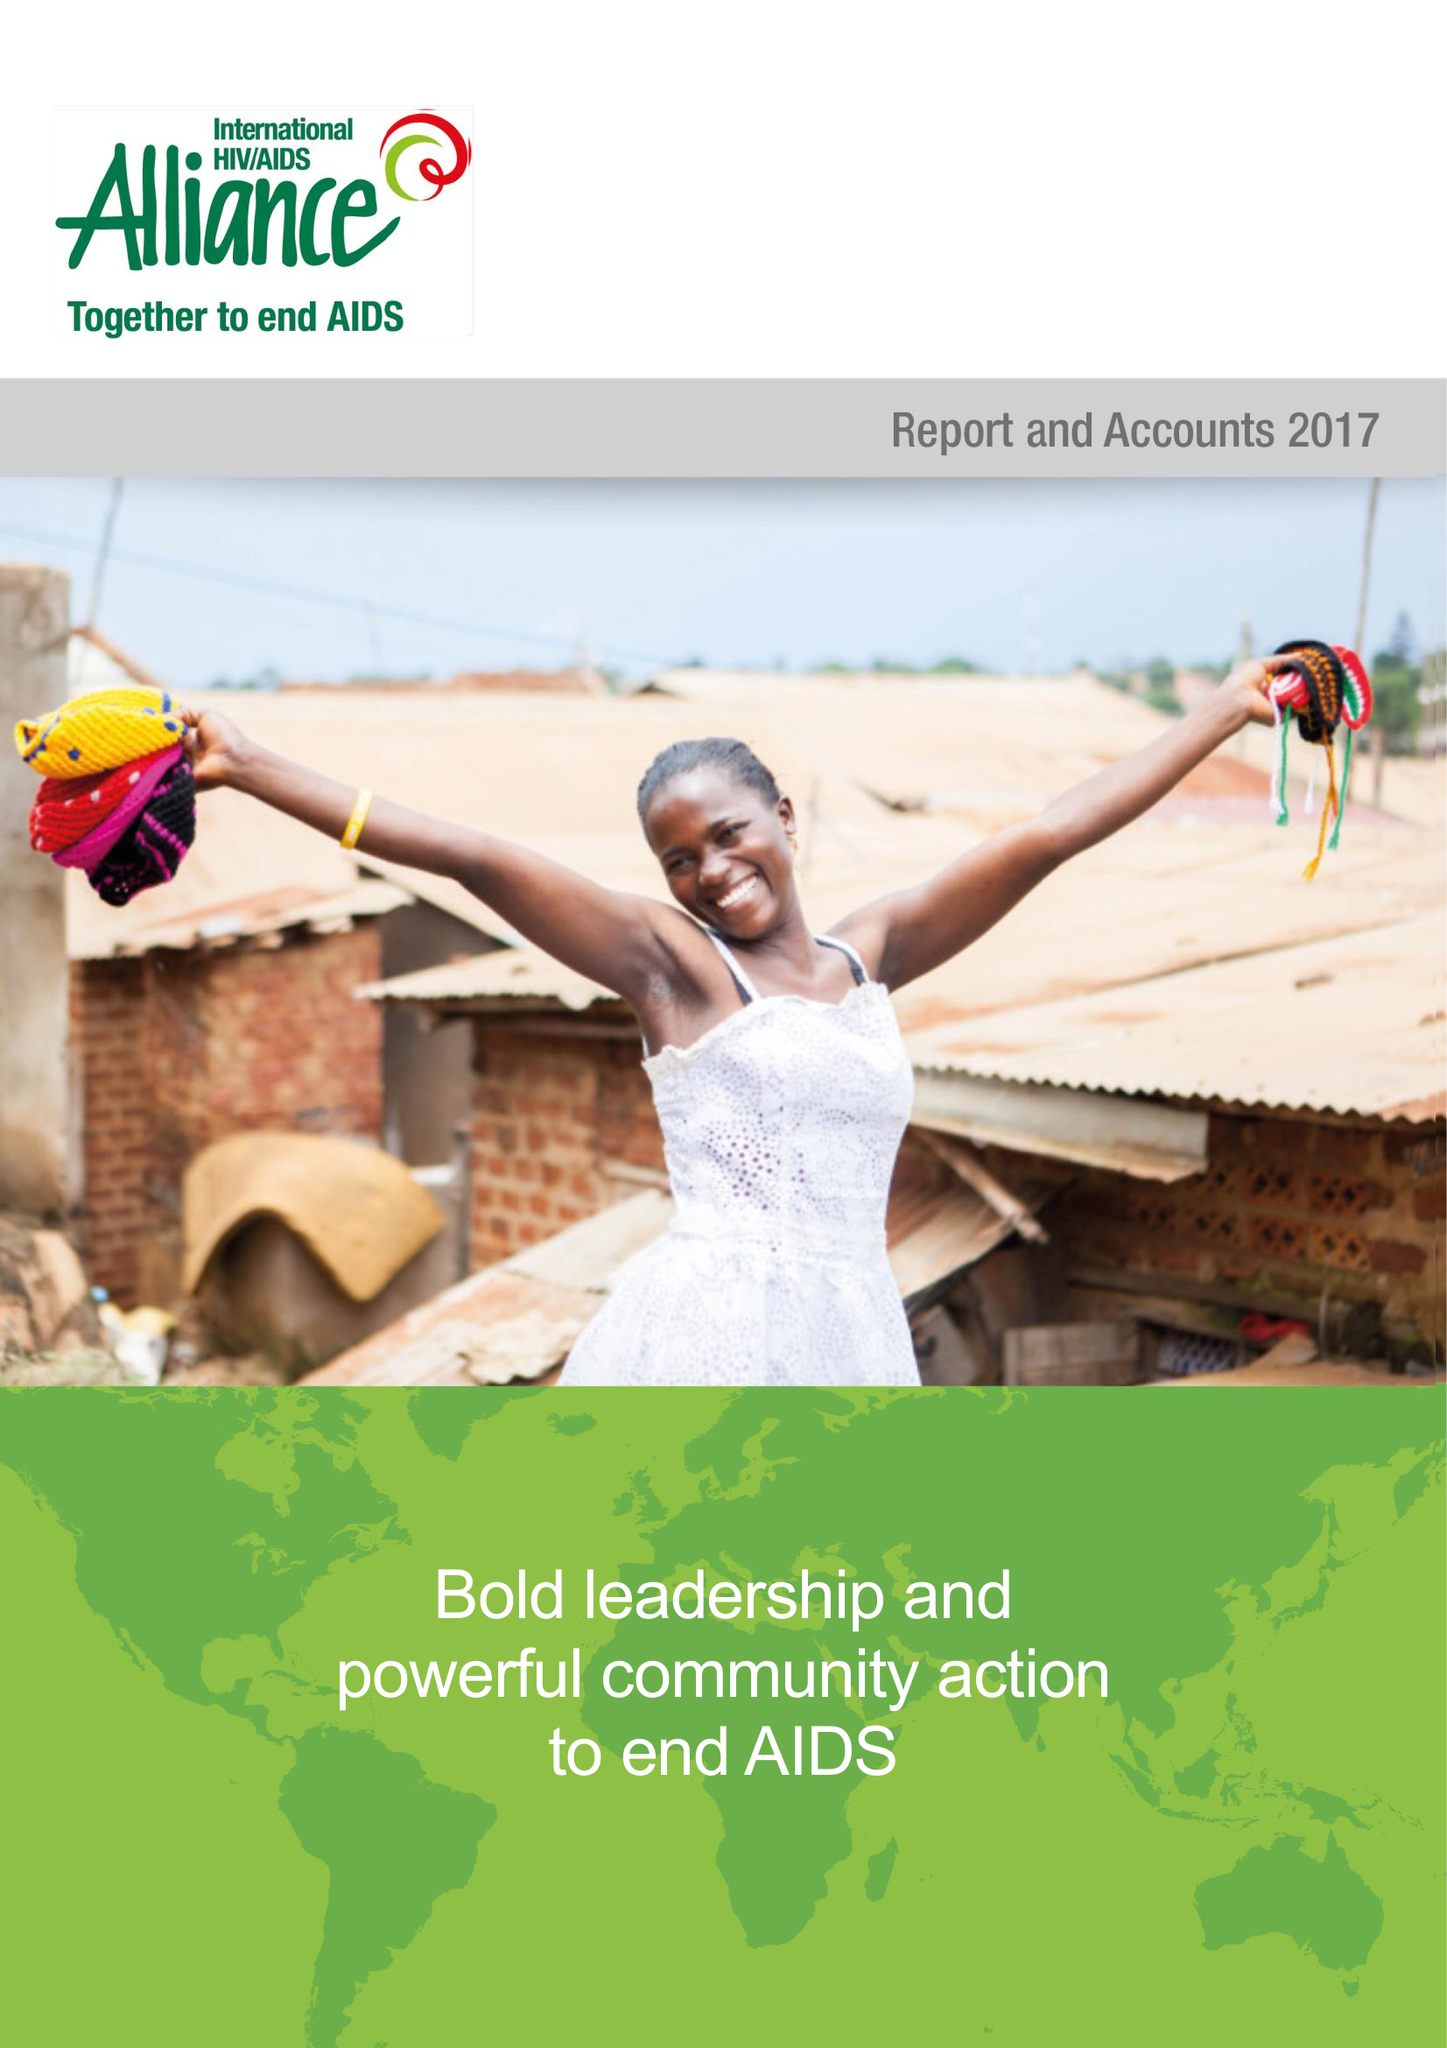What is the value for the report_date?
Answer the question using a single word or phrase. 2017-12-31 